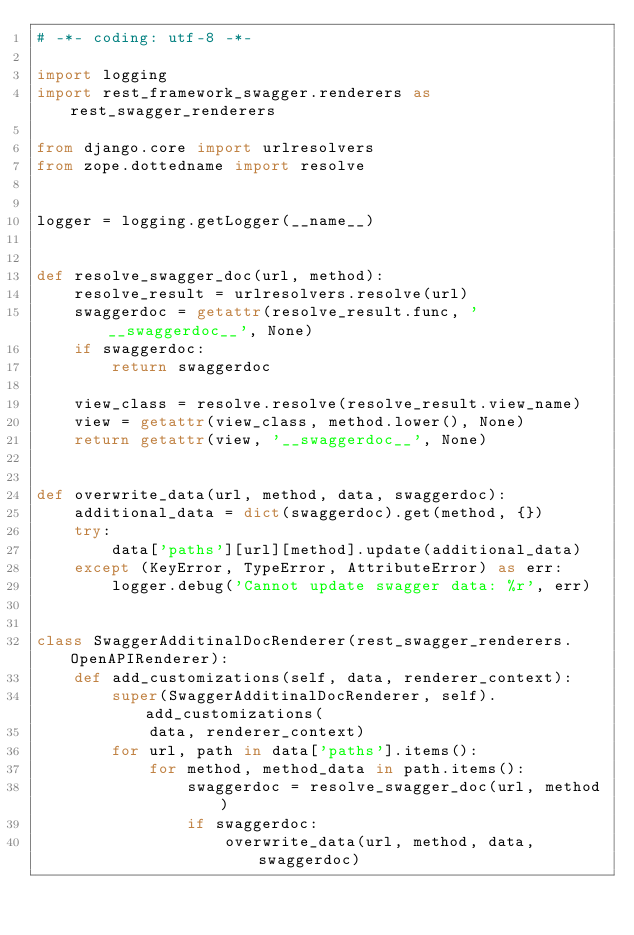<code> <loc_0><loc_0><loc_500><loc_500><_Python_># -*- coding: utf-8 -*-

import logging
import rest_framework_swagger.renderers as rest_swagger_renderers

from django.core import urlresolvers
from zope.dottedname import resolve


logger = logging.getLogger(__name__)


def resolve_swagger_doc(url, method):
    resolve_result = urlresolvers.resolve(url)
    swaggerdoc = getattr(resolve_result.func, '__swaggerdoc__', None)
    if swaggerdoc:
        return swaggerdoc

    view_class = resolve.resolve(resolve_result.view_name)
    view = getattr(view_class, method.lower(), None)
    return getattr(view, '__swaggerdoc__', None)


def overwrite_data(url, method, data, swaggerdoc):
    additional_data = dict(swaggerdoc).get(method, {})
    try:
        data['paths'][url][method].update(additional_data)
    except (KeyError, TypeError, AttributeError) as err:
        logger.debug('Cannot update swagger data: %r', err)


class SwaggerAdditinalDocRenderer(rest_swagger_renderers.OpenAPIRenderer):
    def add_customizations(self, data, renderer_context):
        super(SwaggerAdditinalDocRenderer, self).add_customizations(
            data, renderer_context)
        for url, path in data['paths'].items():
            for method, method_data in path.items():
                swaggerdoc = resolve_swagger_doc(url, method)
                if swaggerdoc:
                    overwrite_data(url, method, data, swaggerdoc)
</code> 